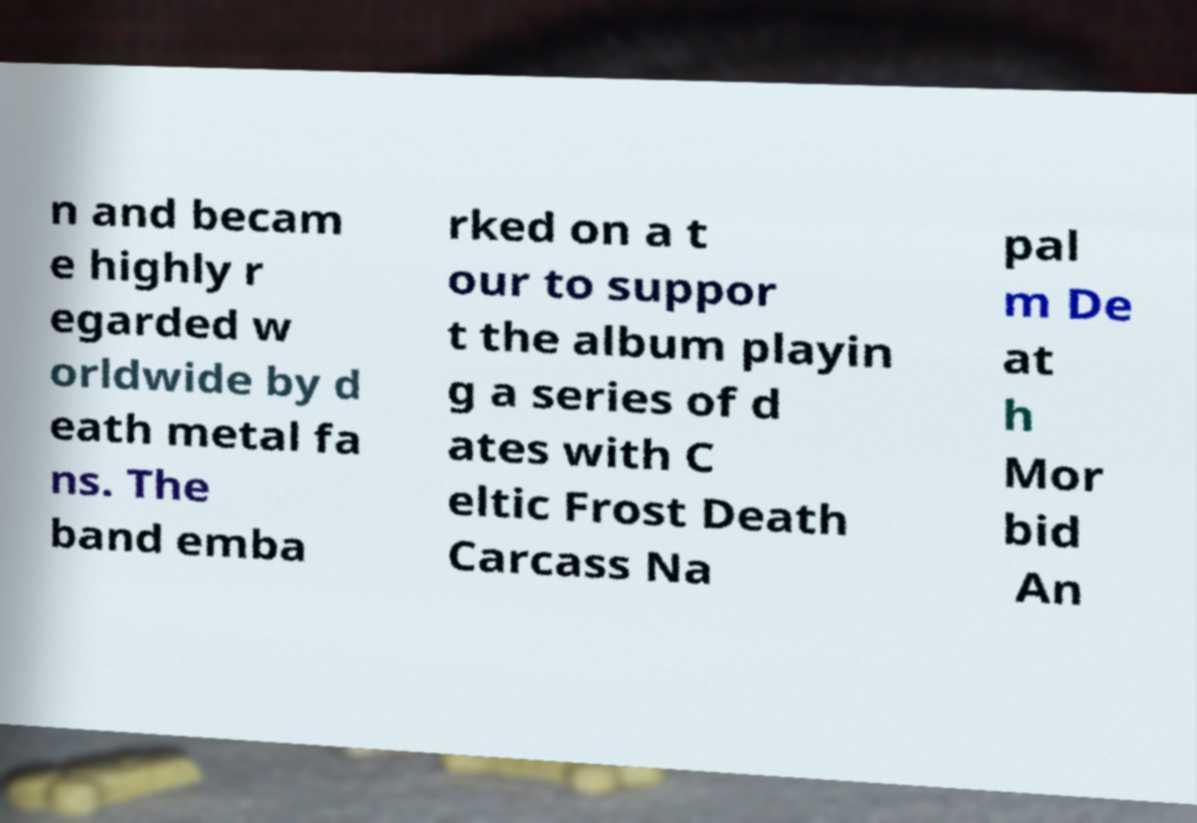Could you extract and type out the text from this image? n and becam e highly r egarded w orldwide by d eath metal fa ns. The band emba rked on a t our to suppor t the album playin g a series of d ates with C eltic Frost Death Carcass Na pal m De at h Mor bid An 